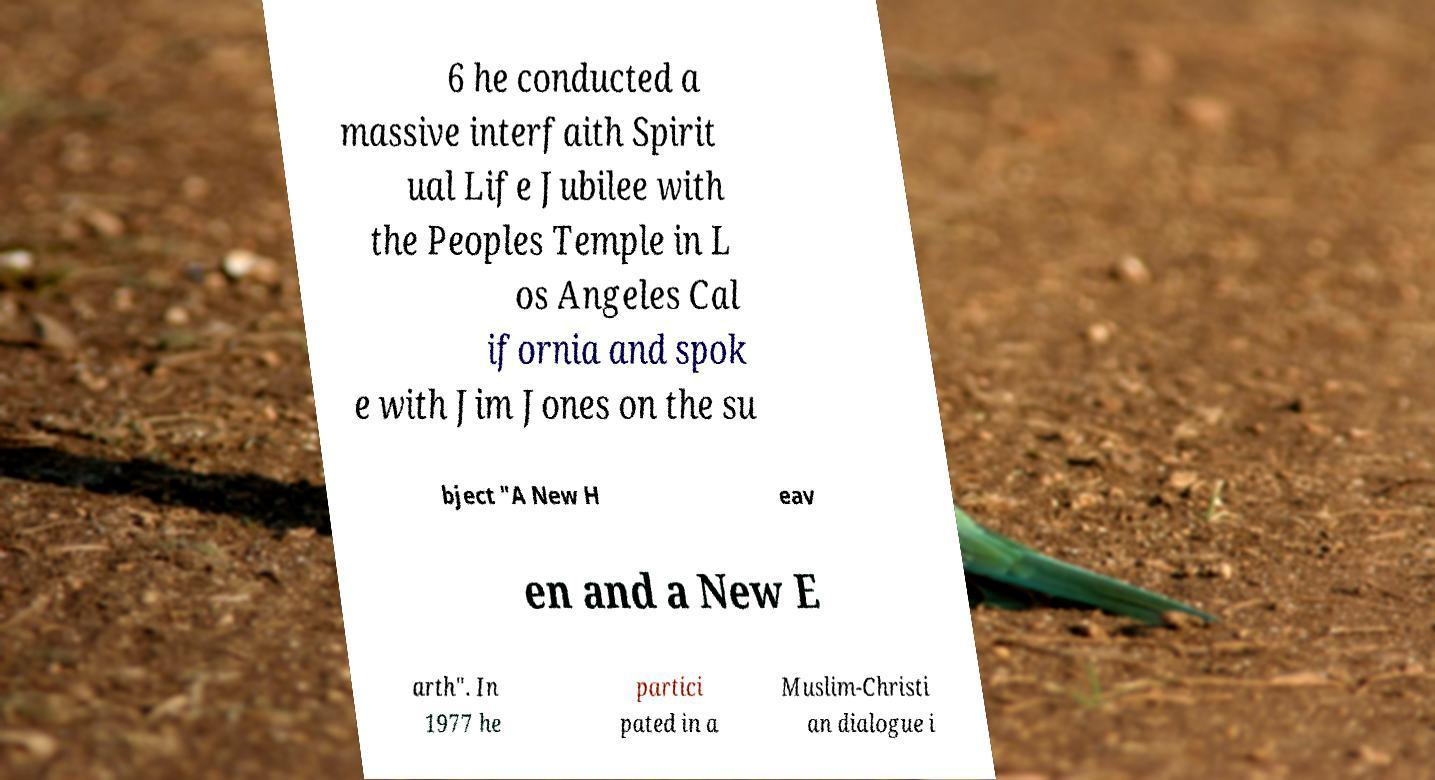Please read and relay the text visible in this image. What does it say? 6 he conducted a massive interfaith Spirit ual Life Jubilee with the Peoples Temple in L os Angeles Cal ifornia and spok e with Jim Jones on the su bject "A New H eav en and a New E arth". In 1977 he partici pated in a Muslim-Christi an dialogue i 